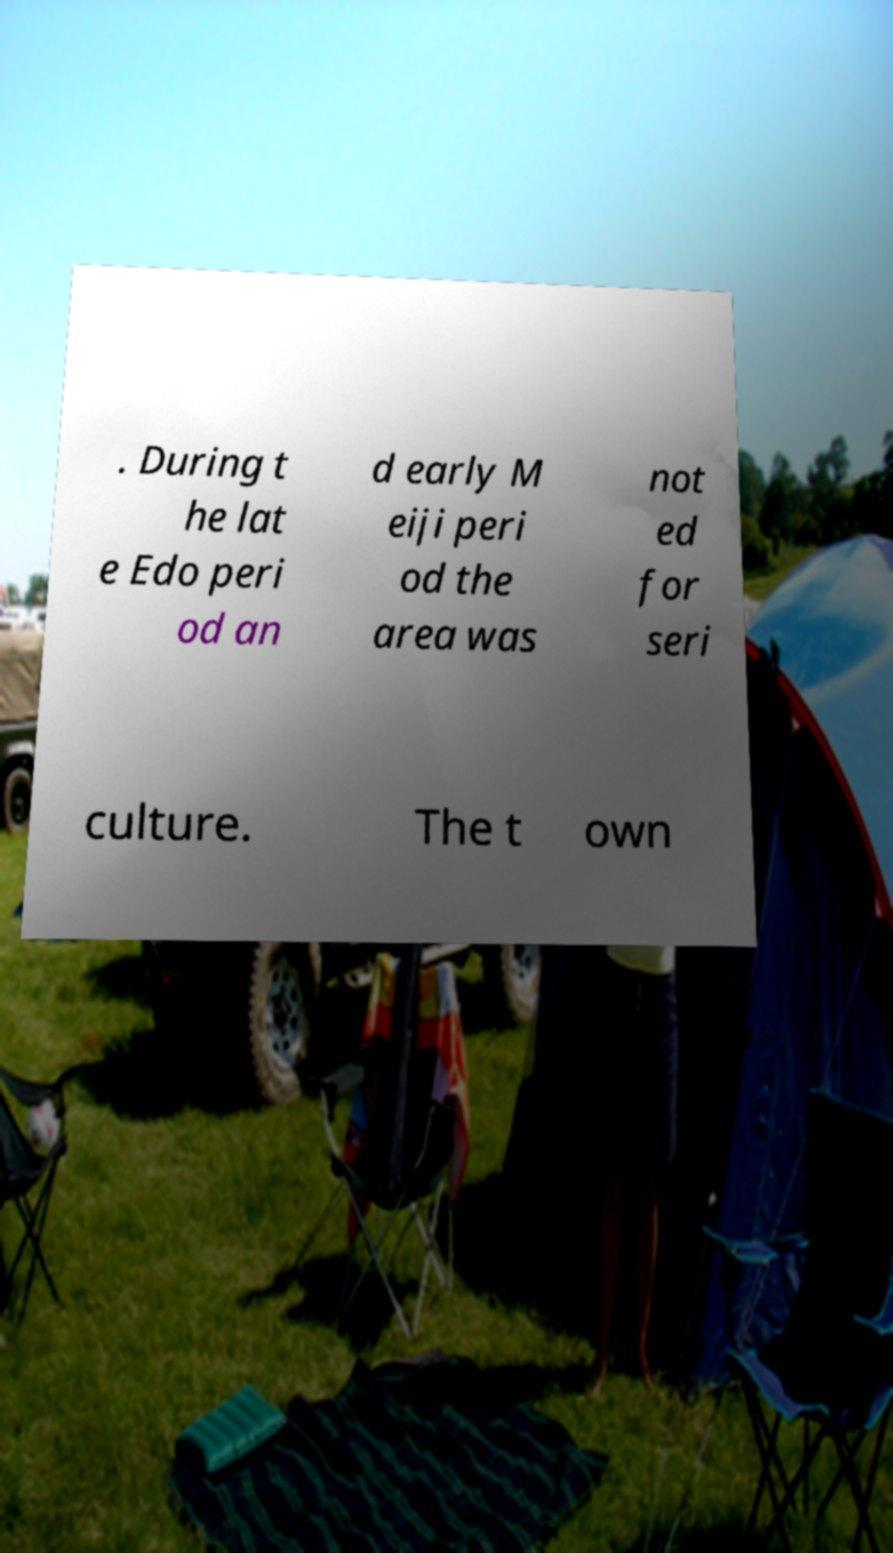Please read and relay the text visible in this image. What does it say? . During t he lat e Edo peri od an d early M eiji peri od the area was not ed for seri culture. The t own 